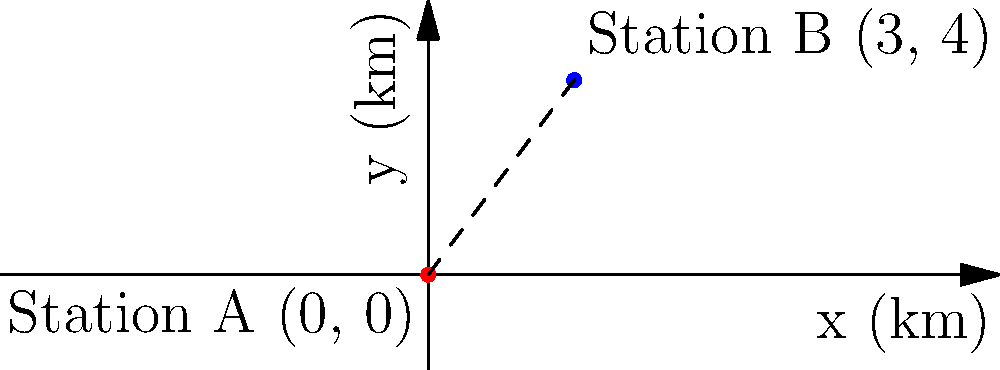Two weather stations, A and B, are located on a coordinate grid where each unit represents 1 kilometer. Station A is at the origin (0, 0), and Station B is at coordinates (3, 4). Calculate the straight-line distance between these two weather stations to the nearest tenth of a kilometer. To solve this problem, we can use the distance formula derived from the Pythagorean theorem. The distance formula for two points $(x_1, y_1)$ and $(x_2, y_2)$ is:

$$ d = \sqrt{(x_2 - x_1)^2 + (y_2 - y_1)^2} $$

Let's apply this formula to our problem:

1) Identify the coordinates:
   Station A: $(x_1, y_1) = (0, 0)$
   Station B: $(x_2, y_2) = (3, 4)$

2) Plug these values into the distance formula:
   $$ d = \sqrt{(3 - 0)^2 + (4 - 0)^2} $$

3) Simplify:
   $$ d = \sqrt{3^2 + 4^2} $$
   $$ d = \sqrt{9 + 16} $$
   $$ d = \sqrt{25} $$

4) Calculate the square root:
   $$ d = 5 $$

5) The question asks for the answer to the nearest tenth of a kilometer, but 5 km is already in that form.

Therefore, the straight-line distance between the two weather stations is 5.0 km.
Answer: 5.0 km 